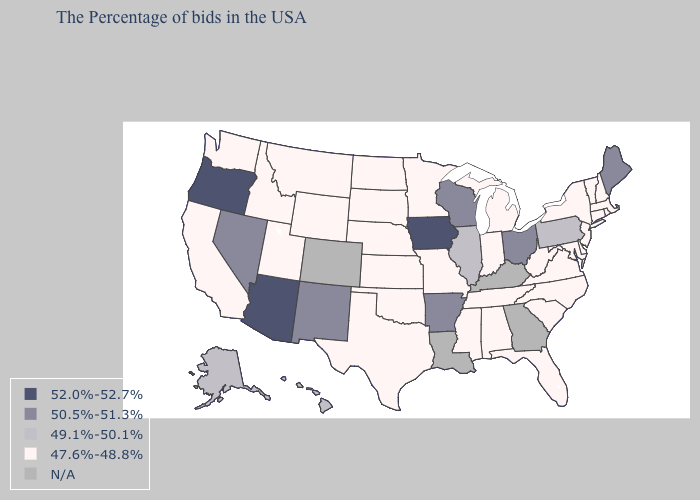Which states have the highest value in the USA?
Give a very brief answer. Iowa, Arizona, Oregon. Does Oklahoma have the lowest value in the South?
Be succinct. Yes. Name the states that have a value in the range 47.6%-48.8%?
Answer briefly. Massachusetts, Rhode Island, New Hampshire, Vermont, Connecticut, New York, New Jersey, Delaware, Maryland, Virginia, North Carolina, South Carolina, West Virginia, Florida, Michigan, Indiana, Alabama, Tennessee, Mississippi, Missouri, Minnesota, Kansas, Nebraska, Oklahoma, Texas, South Dakota, North Dakota, Wyoming, Utah, Montana, Idaho, California, Washington. Name the states that have a value in the range 47.6%-48.8%?
Answer briefly. Massachusetts, Rhode Island, New Hampshire, Vermont, Connecticut, New York, New Jersey, Delaware, Maryland, Virginia, North Carolina, South Carolina, West Virginia, Florida, Michigan, Indiana, Alabama, Tennessee, Mississippi, Missouri, Minnesota, Kansas, Nebraska, Oklahoma, Texas, South Dakota, North Dakota, Wyoming, Utah, Montana, Idaho, California, Washington. Name the states that have a value in the range 49.1%-50.1%?
Short answer required. Pennsylvania, Illinois, Alaska, Hawaii. What is the lowest value in the USA?
Keep it brief. 47.6%-48.8%. What is the lowest value in the USA?
Short answer required. 47.6%-48.8%. Name the states that have a value in the range N/A?
Quick response, please. Georgia, Kentucky, Louisiana, Colorado. Among the states that border Iowa , does Illinois have the lowest value?
Quick response, please. No. What is the lowest value in the USA?
Give a very brief answer. 47.6%-48.8%. Does Nevada have the lowest value in the West?
Quick response, please. No. Among the states that border Delaware , does Pennsylvania have the lowest value?
Keep it brief. No. Which states have the highest value in the USA?
Give a very brief answer. Iowa, Arizona, Oregon. How many symbols are there in the legend?
Give a very brief answer. 5. Among the states that border Illinois , which have the highest value?
Short answer required. Iowa. 